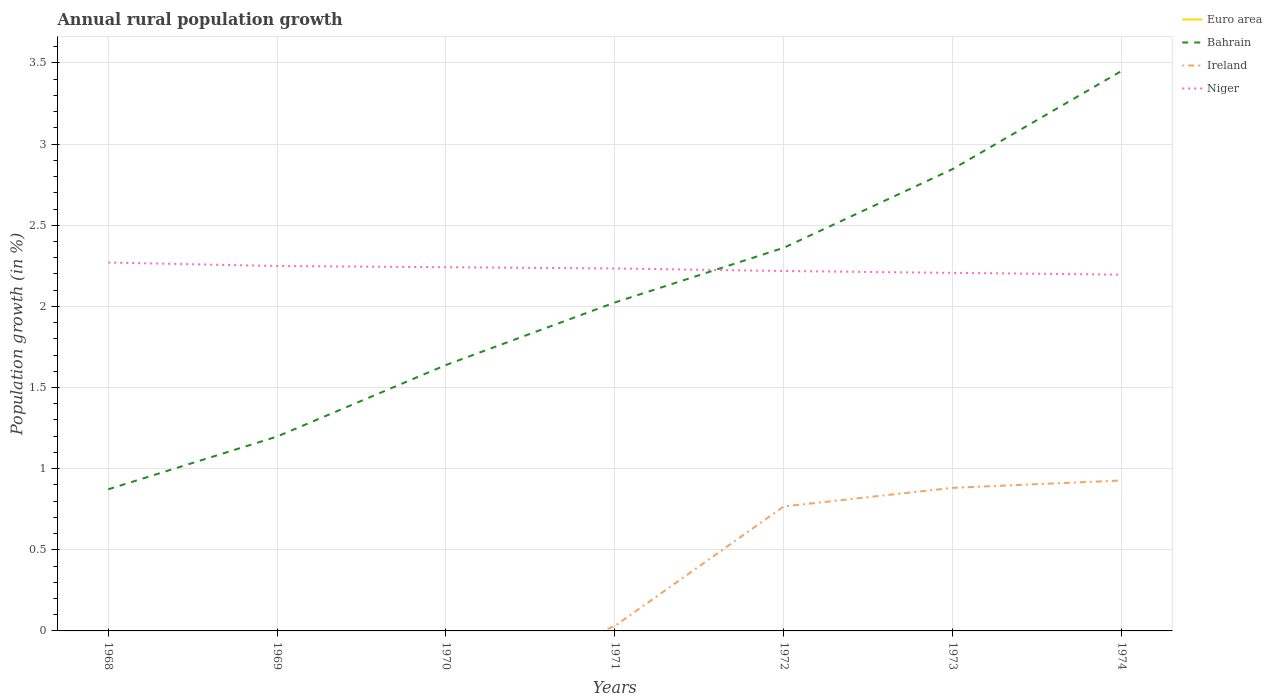Does the line corresponding to Euro area intersect with the line corresponding to Ireland?
Your response must be concise. Yes. Across all years, what is the maximum percentage of rural population growth in Ireland?
Give a very brief answer. 0. What is the total percentage of rural population growth in Bahrain in the graph?
Provide a short and direct response. -0.82. What is the difference between the highest and the second highest percentage of rural population growth in Bahrain?
Offer a very short reply. 2.58. What is the difference between the highest and the lowest percentage of rural population growth in Niger?
Your response must be concise. 4. How many lines are there?
Your answer should be very brief. 3. What is the difference between two consecutive major ticks on the Y-axis?
Your response must be concise. 0.5. Are the values on the major ticks of Y-axis written in scientific E-notation?
Keep it short and to the point. No. Where does the legend appear in the graph?
Provide a short and direct response. Top right. What is the title of the graph?
Provide a short and direct response. Annual rural population growth. Does "Maldives" appear as one of the legend labels in the graph?
Your answer should be compact. No. What is the label or title of the X-axis?
Your response must be concise. Years. What is the label or title of the Y-axis?
Give a very brief answer. Population growth (in %). What is the Population growth (in %) of Bahrain in 1968?
Keep it short and to the point. 0.87. What is the Population growth (in %) of Niger in 1968?
Offer a terse response. 2.27. What is the Population growth (in %) in Euro area in 1969?
Keep it short and to the point. 0. What is the Population growth (in %) in Bahrain in 1969?
Your response must be concise. 1.2. What is the Population growth (in %) in Niger in 1969?
Offer a terse response. 2.25. What is the Population growth (in %) of Bahrain in 1970?
Your response must be concise. 1.64. What is the Population growth (in %) in Niger in 1970?
Provide a short and direct response. 2.24. What is the Population growth (in %) in Bahrain in 1971?
Make the answer very short. 2.02. What is the Population growth (in %) of Ireland in 1971?
Offer a terse response. 0.03. What is the Population growth (in %) in Niger in 1971?
Your response must be concise. 2.23. What is the Population growth (in %) in Bahrain in 1972?
Offer a terse response. 2.36. What is the Population growth (in %) of Ireland in 1972?
Give a very brief answer. 0.77. What is the Population growth (in %) in Niger in 1972?
Make the answer very short. 2.22. What is the Population growth (in %) in Euro area in 1973?
Provide a short and direct response. 0. What is the Population growth (in %) in Bahrain in 1973?
Keep it short and to the point. 2.85. What is the Population growth (in %) in Ireland in 1973?
Your response must be concise. 0.88. What is the Population growth (in %) of Niger in 1973?
Give a very brief answer. 2.21. What is the Population growth (in %) of Bahrain in 1974?
Make the answer very short. 3.45. What is the Population growth (in %) of Ireland in 1974?
Offer a very short reply. 0.93. What is the Population growth (in %) of Niger in 1974?
Give a very brief answer. 2.2. Across all years, what is the maximum Population growth (in %) in Bahrain?
Ensure brevity in your answer.  3.45. Across all years, what is the maximum Population growth (in %) in Ireland?
Your answer should be very brief. 0.93. Across all years, what is the maximum Population growth (in %) in Niger?
Offer a terse response. 2.27. Across all years, what is the minimum Population growth (in %) of Bahrain?
Give a very brief answer. 0.87. Across all years, what is the minimum Population growth (in %) of Niger?
Provide a short and direct response. 2.2. What is the total Population growth (in %) of Euro area in the graph?
Your answer should be very brief. 0. What is the total Population growth (in %) of Bahrain in the graph?
Your response must be concise. 14.39. What is the total Population growth (in %) of Ireland in the graph?
Your response must be concise. 2.61. What is the total Population growth (in %) in Niger in the graph?
Your response must be concise. 15.61. What is the difference between the Population growth (in %) in Bahrain in 1968 and that in 1969?
Your response must be concise. -0.33. What is the difference between the Population growth (in %) of Niger in 1968 and that in 1969?
Give a very brief answer. 0.02. What is the difference between the Population growth (in %) in Bahrain in 1968 and that in 1970?
Offer a terse response. -0.77. What is the difference between the Population growth (in %) in Niger in 1968 and that in 1970?
Offer a terse response. 0.03. What is the difference between the Population growth (in %) of Bahrain in 1968 and that in 1971?
Offer a terse response. -1.15. What is the difference between the Population growth (in %) of Niger in 1968 and that in 1971?
Offer a terse response. 0.04. What is the difference between the Population growth (in %) in Bahrain in 1968 and that in 1972?
Keep it short and to the point. -1.49. What is the difference between the Population growth (in %) of Niger in 1968 and that in 1972?
Your answer should be compact. 0.05. What is the difference between the Population growth (in %) of Bahrain in 1968 and that in 1973?
Provide a short and direct response. -1.97. What is the difference between the Population growth (in %) in Niger in 1968 and that in 1973?
Offer a terse response. 0.06. What is the difference between the Population growth (in %) in Bahrain in 1968 and that in 1974?
Offer a very short reply. -2.58. What is the difference between the Population growth (in %) in Niger in 1968 and that in 1974?
Offer a very short reply. 0.07. What is the difference between the Population growth (in %) in Bahrain in 1969 and that in 1970?
Provide a succinct answer. -0.44. What is the difference between the Population growth (in %) of Niger in 1969 and that in 1970?
Offer a very short reply. 0.01. What is the difference between the Population growth (in %) of Bahrain in 1969 and that in 1971?
Make the answer very short. -0.83. What is the difference between the Population growth (in %) of Niger in 1969 and that in 1971?
Your answer should be very brief. 0.02. What is the difference between the Population growth (in %) in Bahrain in 1969 and that in 1972?
Offer a very short reply. -1.16. What is the difference between the Population growth (in %) in Niger in 1969 and that in 1972?
Provide a short and direct response. 0.03. What is the difference between the Population growth (in %) of Bahrain in 1969 and that in 1973?
Your answer should be compact. -1.65. What is the difference between the Population growth (in %) of Niger in 1969 and that in 1973?
Ensure brevity in your answer.  0.04. What is the difference between the Population growth (in %) of Bahrain in 1969 and that in 1974?
Provide a succinct answer. -2.25. What is the difference between the Population growth (in %) in Niger in 1969 and that in 1974?
Provide a short and direct response. 0.05. What is the difference between the Population growth (in %) in Bahrain in 1970 and that in 1971?
Ensure brevity in your answer.  -0.39. What is the difference between the Population growth (in %) in Niger in 1970 and that in 1971?
Your answer should be very brief. 0.01. What is the difference between the Population growth (in %) of Bahrain in 1970 and that in 1972?
Offer a terse response. -0.72. What is the difference between the Population growth (in %) in Niger in 1970 and that in 1972?
Give a very brief answer. 0.02. What is the difference between the Population growth (in %) in Bahrain in 1970 and that in 1973?
Offer a very short reply. -1.21. What is the difference between the Population growth (in %) in Niger in 1970 and that in 1973?
Keep it short and to the point. 0.04. What is the difference between the Population growth (in %) of Bahrain in 1970 and that in 1974?
Offer a very short reply. -1.81. What is the difference between the Population growth (in %) in Niger in 1970 and that in 1974?
Your answer should be very brief. 0.05. What is the difference between the Population growth (in %) in Bahrain in 1971 and that in 1972?
Your answer should be very brief. -0.34. What is the difference between the Population growth (in %) of Ireland in 1971 and that in 1972?
Offer a very short reply. -0.74. What is the difference between the Population growth (in %) of Niger in 1971 and that in 1972?
Your response must be concise. 0.02. What is the difference between the Population growth (in %) of Bahrain in 1971 and that in 1973?
Offer a terse response. -0.82. What is the difference between the Population growth (in %) in Ireland in 1971 and that in 1973?
Offer a very short reply. -0.85. What is the difference between the Population growth (in %) in Niger in 1971 and that in 1973?
Your answer should be very brief. 0.03. What is the difference between the Population growth (in %) of Bahrain in 1971 and that in 1974?
Offer a very short reply. -1.43. What is the difference between the Population growth (in %) of Ireland in 1971 and that in 1974?
Your response must be concise. -0.9. What is the difference between the Population growth (in %) in Niger in 1971 and that in 1974?
Make the answer very short. 0.04. What is the difference between the Population growth (in %) of Bahrain in 1972 and that in 1973?
Offer a very short reply. -0.49. What is the difference between the Population growth (in %) in Ireland in 1972 and that in 1973?
Keep it short and to the point. -0.11. What is the difference between the Population growth (in %) of Niger in 1972 and that in 1973?
Offer a very short reply. 0.01. What is the difference between the Population growth (in %) of Bahrain in 1972 and that in 1974?
Ensure brevity in your answer.  -1.09. What is the difference between the Population growth (in %) in Ireland in 1972 and that in 1974?
Offer a very short reply. -0.16. What is the difference between the Population growth (in %) of Niger in 1972 and that in 1974?
Provide a short and direct response. 0.02. What is the difference between the Population growth (in %) of Bahrain in 1973 and that in 1974?
Provide a short and direct response. -0.6. What is the difference between the Population growth (in %) in Ireland in 1973 and that in 1974?
Your response must be concise. -0.05. What is the difference between the Population growth (in %) in Niger in 1973 and that in 1974?
Give a very brief answer. 0.01. What is the difference between the Population growth (in %) in Bahrain in 1968 and the Population growth (in %) in Niger in 1969?
Give a very brief answer. -1.38. What is the difference between the Population growth (in %) of Bahrain in 1968 and the Population growth (in %) of Niger in 1970?
Keep it short and to the point. -1.37. What is the difference between the Population growth (in %) of Bahrain in 1968 and the Population growth (in %) of Ireland in 1971?
Your answer should be very brief. 0.84. What is the difference between the Population growth (in %) of Bahrain in 1968 and the Population growth (in %) of Niger in 1971?
Provide a succinct answer. -1.36. What is the difference between the Population growth (in %) of Bahrain in 1968 and the Population growth (in %) of Ireland in 1972?
Give a very brief answer. 0.11. What is the difference between the Population growth (in %) of Bahrain in 1968 and the Population growth (in %) of Niger in 1972?
Provide a succinct answer. -1.35. What is the difference between the Population growth (in %) in Bahrain in 1968 and the Population growth (in %) in Ireland in 1973?
Keep it short and to the point. -0.01. What is the difference between the Population growth (in %) in Bahrain in 1968 and the Population growth (in %) in Niger in 1973?
Provide a succinct answer. -1.33. What is the difference between the Population growth (in %) of Bahrain in 1968 and the Population growth (in %) of Ireland in 1974?
Your response must be concise. -0.05. What is the difference between the Population growth (in %) of Bahrain in 1968 and the Population growth (in %) of Niger in 1974?
Give a very brief answer. -1.32. What is the difference between the Population growth (in %) of Bahrain in 1969 and the Population growth (in %) of Niger in 1970?
Provide a succinct answer. -1.04. What is the difference between the Population growth (in %) in Bahrain in 1969 and the Population growth (in %) in Ireland in 1971?
Your response must be concise. 1.17. What is the difference between the Population growth (in %) of Bahrain in 1969 and the Population growth (in %) of Niger in 1971?
Your answer should be compact. -1.04. What is the difference between the Population growth (in %) of Bahrain in 1969 and the Population growth (in %) of Ireland in 1972?
Ensure brevity in your answer.  0.43. What is the difference between the Population growth (in %) of Bahrain in 1969 and the Population growth (in %) of Niger in 1972?
Offer a terse response. -1.02. What is the difference between the Population growth (in %) of Bahrain in 1969 and the Population growth (in %) of Ireland in 1973?
Make the answer very short. 0.32. What is the difference between the Population growth (in %) of Bahrain in 1969 and the Population growth (in %) of Niger in 1973?
Offer a terse response. -1.01. What is the difference between the Population growth (in %) of Bahrain in 1969 and the Population growth (in %) of Ireland in 1974?
Make the answer very short. 0.27. What is the difference between the Population growth (in %) of Bahrain in 1969 and the Population growth (in %) of Niger in 1974?
Give a very brief answer. -1. What is the difference between the Population growth (in %) of Bahrain in 1970 and the Population growth (in %) of Ireland in 1971?
Give a very brief answer. 1.61. What is the difference between the Population growth (in %) in Bahrain in 1970 and the Population growth (in %) in Niger in 1971?
Make the answer very short. -0.59. What is the difference between the Population growth (in %) in Bahrain in 1970 and the Population growth (in %) in Ireland in 1972?
Offer a terse response. 0.87. What is the difference between the Population growth (in %) of Bahrain in 1970 and the Population growth (in %) of Niger in 1972?
Provide a short and direct response. -0.58. What is the difference between the Population growth (in %) of Bahrain in 1970 and the Population growth (in %) of Ireland in 1973?
Make the answer very short. 0.76. What is the difference between the Population growth (in %) of Bahrain in 1970 and the Population growth (in %) of Niger in 1973?
Offer a terse response. -0.57. What is the difference between the Population growth (in %) of Bahrain in 1970 and the Population growth (in %) of Ireland in 1974?
Your answer should be very brief. 0.71. What is the difference between the Population growth (in %) in Bahrain in 1970 and the Population growth (in %) in Niger in 1974?
Ensure brevity in your answer.  -0.56. What is the difference between the Population growth (in %) in Bahrain in 1971 and the Population growth (in %) in Ireland in 1972?
Provide a succinct answer. 1.26. What is the difference between the Population growth (in %) in Bahrain in 1971 and the Population growth (in %) in Niger in 1972?
Your response must be concise. -0.19. What is the difference between the Population growth (in %) in Ireland in 1971 and the Population growth (in %) in Niger in 1972?
Your response must be concise. -2.19. What is the difference between the Population growth (in %) in Bahrain in 1971 and the Population growth (in %) in Ireland in 1973?
Give a very brief answer. 1.14. What is the difference between the Population growth (in %) in Bahrain in 1971 and the Population growth (in %) in Niger in 1973?
Make the answer very short. -0.18. What is the difference between the Population growth (in %) in Ireland in 1971 and the Population growth (in %) in Niger in 1973?
Give a very brief answer. -2.18. What is the difference between the Population growth (in %) in Bahrain in 1971 and the Population growth (in %) in Ireland in 1974?
Offer a terse response. 1.1. What is the difference between the Population growth (in %) of Bahrain in 1971 and the Population growth (in %) of Niger in 1974?
Your answer should be compact. -0.17. What is the difference between the Population growth (in %) of Ireland in 1971 and the Population growth (in %) of Niger in 1974?
Give a very brief answer. -2.17. What is the difference between the Population growth (in %) in Bahrain in 1972 and the Population growth (in %) in Ireland in 1973?
Offer a terse response. 1.48. What is the difference between the Population growth (in %) in Bahrain in 1972 and the Population growth (in %) in Niger in 1973?
Make the answer very short. 0.15. What is the difference between the Population growth (in %) in Ireland in 1972 and the Population growth (in %) in Niger in 1973?
Provide a short and direct response. -1.44. What is the difference between the Population growth (in %) of Bahrain in 1972 and the Population growth (in %) of Ireland in 1974?
Your response must be concise. 1.43. What is the difference between the Population growth (in %) of Bahrain in 1972 and the Population growth (in %) of Niger in 1974?
Your answer should be compact. 0.17. What is the difference between the Population growth (in %) in Ireland in 1972 and the Population growth (in %) in Niger in 1974?
Provide a short and direct response. -1.43. What is the difference between the Population growth (in %) in Bahrain in 1973 and the Population growth (in %) in Ireland in 1974?
Keep it short and to the point. 1.92. What is the difference between the Population growth (in %) in Bahrain in 1973 and the Population growth (in %) in Niger in 1974?
Give a very brief answer. 0.65. What is the difference between the Population growth (in %) of Ireland in 1973 and the Population growth (in %) of Niger in 1974?
Make the answer very short. -1.31. What is the average Population growth (in %) in Euro area per year?
Ensure brevity in your answer.  0. What is the average Population growth (in %) in Bahrain per year?
Keep it short and to the point. 2.06. What is the average Population growth (in %) of Ireland per year?
Offer a very short reply. 0.37. What is the average Population growth (in %) in Niger per year?
Make the answer very short. 2.23. In the year 1968, what is the difference between the Population growth (in %) in Bahrain and Population growth (in %) in Niger?
Give a very brief answer. -1.4. In the year 1969, what is the difference between the Population growth (in %) of Bahrain and Population growth (in %) of Niger?
Offer a very short reply. -1.05. In the year 1970, what is the difference between the Population growth (in %) of Bahrain and Population growth (in %) of Niger?
Your answer should be very brief. -0.6. In the year 1971, what is the difference between the Population growth (in %) of Bahrain and Population growth (in %) of Ireland?
Your answer should be compact. 1.99. In the year 1971, what is the difference between the Population growth (in %) of Bahrain and Population growth (in %) of Niger?
Ensure brevity in your answer.  -0.21. In the year 1971, what is the difference between the Population growth (in %) in Ireland and Population growth (in %) in Niger?
Keep it short and to the point. -2.2. In the year 1972, what is the difference between the Population growth (in %) of Bahrain and Population growth (in %) of Ireland?
Your answer should be compact. 1.59. In the year 1972, what is the difference between the Population growth (in %) in Bahrain and Population growth (in %) in Niger?
Make the answer very short. 0.14. In the year 1972, what is the difference between the Population growth (in %) in Ireland and Population growth (in %) in Niger?
Offer a very short reply. -1.45. In the year 1973, what is the difference between the Population growth (in %) of Bahrain and Population growth (in %) of Ireland?
Provide a succinct answer. 1.96. In the year 1973, what is the difference between the Population growth (in %) in Bahrain and Population growth (in %) in Niger?
Your response must be concise. 0.64. In the year 1973, what is the difference between the Population growth (in %) of Ireland and Population growth (in %) of Niger?
Provide a short and direct response. -1.32. In the year 1974, what is the difference between the Population growth (in %) of Bahrain and Population growth (in %) of Ireland?
Keep it short and to the point. 2.52. In the year 1974, what is the difference between the Population growth (in %) in Bahrain and Population growth (in %) in Niger?
Provide a succinct answer. 1.26. In the year 1974, what is the difference between the Population growth (in %) of Ireland and Population growth (in %) of Niger?
Your answer should be compact. -1.27. What is the ratio of the Population growth (in %) in Bahrain in 1968 to that in 1969?
Make the answer very short. 0.73. What is the ratio of the Population growth (in %) in Niger in 1968 to that in 1969?
Offer a very short reply. 1.01. What is the ratio of the Population growth (in %) in Bahrain in 1968 to that in 1970?
Give a very brief answer. 0.53. What is the ratio of the Population growth (in %) of Niger in 1968 to that in 1970?
Ensure brevity in your answer.  1.01. What is the ratio of the Population growth (in %) in Bahrain in 1968 to that in 1971?
Give a very brief answer. 0.43. What is the ratio of the Population growth (in %) of Niger in 1968 to that in 1971?
Keep it short and to the point. 1.02. What is the ratio of the Population growth (in %) of Bahrain in 1968 to that in 1972?
Your response must be concise. 0.37. What is the ratio of the Population growth (in %) of Niger in 1968 to that in 1972?
Ensure brevity in your answer.  1.02. What is the ratio of the Population growth (in %) of Bahrain in 1968 to that in 1973?
Provide a succinct answer. 0.31. What is the ratio of the Population growth (in %) of Niger in 1968 to that in 1973?
Your answer should be compact. 1.03. What is the ratio of the Population growth (in %) in Bahrain in 1968 to that in 1974?
Ensure brevity in your answer.  0.25. What is the ratio of the Population growth (in %) of Niger in 1968 to that in 1974?
Provide a short and direct response. 1.03. What is the ratio of the Population growth (in %) in Bahrain in 1969 to that in 1970?
Your answer should be very brief. 0.73. What is the ratio of the Population growth (in %) of Niger in 1969 to that in 1970?
Offer a very short reply. 1. What is the ratio of the Population growth (in %) of Bahrain in 1969 to that in 1971?
Provide a short and direct response. 0.59. What is the ratio of the Population growth (in %) of Niger in 1969 to that in 1971?
Keep it short and to the point. 1.01. What is the ratio of the Population growth (in %) of Bahrain in 1969 to that in 1972?
Give a very brief answer. 0.51. What is the ratio of the Population growth (in %) of Niger in 1969 to that in 1972?
Make the answer very short. 1.01. What is the ratio of the Population growth (in %) in Bahrain in 1969 to that in 1973?
Provide a succinct answer. 0.42. What is the ratio of the Population growth (in %) in Niger in 1969 to that in 1973?
Your answer should be very brief. 1.02. What is the ratio of the Population growth (in %) in Bahrain in 1969 to that in 1974?
Offer a very short reply. 0.35. What is the ratio of the Population growth (in %) of Niger in 1969 to that in 1974?
Your answer should be very brief. 1.02. What is the ratio of the Population growth (in %) of Bahrain in 1970 to that in 1971?
Make the answer very short. 0.81. What is the ratio of the Population growth (in %) in Niger in 1970 to that in 1971?
Your answer should be very brief. 1. What is the ratio of the Population growth (in %) of Bahrain in 1970 to that in 1972?
Keep it short and to the point. 0.69. What is the ratio of the Population growth (in %) in Niger in 1970 to that in 1972?
Your response must be concise. 1.01. What is the ratio of the Population growth (in %) of Bahrain in 1970 to that in 1973?
Make the answer very short. 0.58. What is the ratio of the Population growth (in %) in Niger in 1970 to that in 1973?
Make the answer very short. 1.02. What is the ratio of the Population growth (in %) of Bahrain in 1970 to that in 1974?
Your answer should be very brief. 0.47. What is the ratio of the Population growth (in %) of Niger in 1970 to that in 1974?
Offer a terse response. 1.02. What is the ratio of the Population growth (in %) in Bahrain in 1971 to that in 1972?
Make the answer very short. 0.86. What is the ratio of the Population growth (in %) in Ireland in 1971 to that in 1972?
Ensure brevity in your answer.  0.04. What is the ratio of the Population growth (in %) in Niger in 1971 to that in 1972?
Your answer should be compact. 1.01. What is the ratio of the Population growth (in %) in Bahrain in 1971 to that in 1973?
Provide a succinct answer. 0.71. What is the ratio of the Population growth (in %) in Ireland in 1971 to that in 1973?
Ensure brevity in your answer.  0.03. What is the ratio of the Population growth (in %) in Niger in 1971 to that in 1973?
Keep it short and to the point. 1.01. What is the ratio of the Population growth (in %) of Bahrain in 1971 to that in 1974?
Your answer should be very brief. 0.59. What is the ratio of the Population growth (in %) of Ireland in 1971 to that in 1974?
Your answer should be compact. 0.03. What is the ratio of the Population growth (in %) of Niger in 1971 to that in 1974?
Your response must be concise. 1.02. What is the ratio of the Population growth (in %) of Bahrain in 1972 to that in 1973?
Ensure brevity in your answer.  0.83. What is the ratio of the Population growth (in %) in Ireland in 1972 to that in 1973?
Keep it short and to the point. 0.87. What is the ratio of the Population growth (in %) of Niger in 1972 to that in 1973?
Provide a succinct answer. 1.01. What is the ratio of the Population growth (in %) of Bahrain in 1972 to that in 1974?
Your answer should be compact. 0.68. What is the ratio of the Population growth (in %) in Ireland in 1972 to that in 1974?
Your answer should be very brief. 0.83. What is the ratio of the Population growth (in %) of Niger in 1972 to that in 1974?
Offer a very short reply. 1.01. What is the ratio of the Population growth (in %) of Bahrain in 1973 to that in 1974?
Provide a short and direct response. 0.82. What is the ratio of the Population growth (in %) of Ireland in 1973 to that in 1974?
Keep it short and to the point. 0.95. What is the ratio of the Population growth (in %) of Niger in 1973 to that in 1974?
Give a very brief answer. 1. What is the difference between the highest and the second highest Population growth (in %) of Bahrain?
Your answer should be compact. 0.6. What is the difference between the highest and the second highest Population growth (in %) of Ireland?
Offer a terse response. 0.05. What is the difference between the highest and the second highest Population growth (in %) of Niger?
Provide a short and direct response. 0.02. What is the difference between the highest and the lowest Population growth (in %) in Bahrain?
Your response must be concise. 2.58. What is the difference between the highest and the lowest Population growth (in %) in Ireland?
Provide a short and direct response. 0.93. What is the difference between the highest and the lowest Population growth (in %) in Niger?
Offer a terse response. 0.07. 